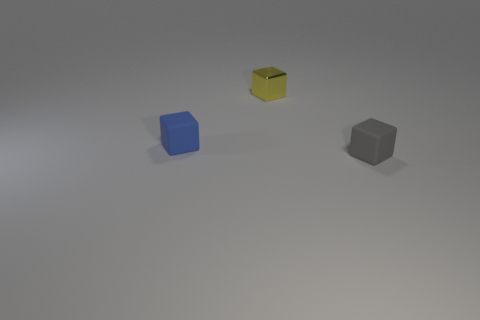How many blocks are in front of the tiny rubber thing that is to the left of the yellow metal cube?
Your response must be concise. 1. What material is the gray thing that is the same shape as the blue matte thing?
Provide a short and direct response. Rubber. What number of gray things are either metal blocks or tiny rubber cylinders?
Your response must be concise. 0. Are there any other things of the same color as the small shiny object?
Keep it short and to the point. No. What is the color of the thing behind the small rubber object to the left of the gray thing?
Your answer should be very brief. Yellow. Are there fewer small gray blocks that are behind the yellow metallic block than small gray matte things left of the blue matte object?
Offer a very short reply. No. How many objects are matte blocks that are in front of the small blue matte object or tiny blue things?
Give a very brief answer. 2. Is the size of the matte object on the right side of the yellow metal cube the same as the tiny blue block?
Your answer should be very brief. Yes. Is the number of cubes to the left of the small yellow metallic thing less than the number of yellow balls?
Give a very brief answer. No. What is the material of the blue block that is the same size as the yellow block?
Provide a short and direct response. Rubber. 